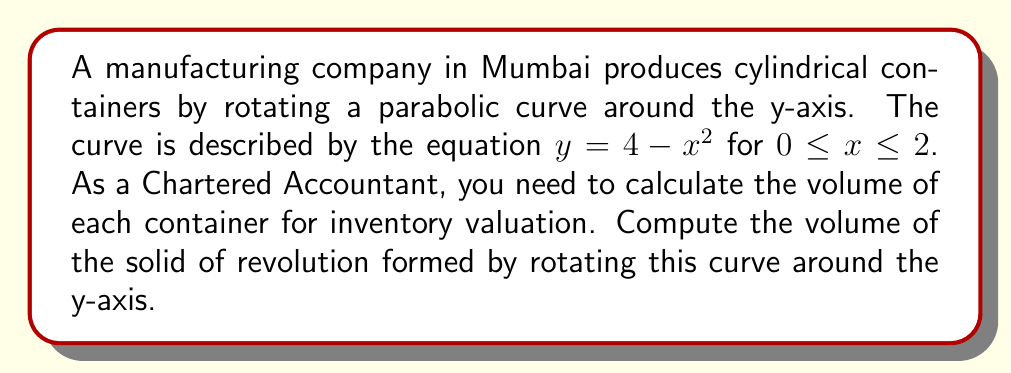Provide a solution to this math problem. Let's approach this step-by-step:

1) The volume of a solid of revolution around the y-axis is given by the formula:

   $$V = \pi \int_a^b [f(x)]^2 dx$$

   where $f(x)$ is the function being rotated, and $a$ and $b$ are the limits of rotation.

2) In this case, $f(x) = 2 - \sqrt{4-y} = x$, and we're rotating from $x = 0$ to $x = 2$.

3) Substituting into the formula:

   $$V = \pi \int_0^2 x^2 dx$$

4) Evaluating the integral:

   $$V = \pi \left[\frac{x^3}{3}\right]_0^2$$

5) Calculating the result:

   $$V = \pi \left(\frac{2^3}{3} - \frac{0^3}{3}\right) = \pi \left(\frac{8}{3}\right) = \frac{8\pi}{3}$$

6) Therefore, the volume of each container is $\frac{8\pi}{3}$ cubic units.

As a Chartered Accountant, you would use this volume to calculate the value of inventory, considering the material cost per unit volume and the number of containers produced.
Answer: $\frac{8\pi}{3}$ cubic units 